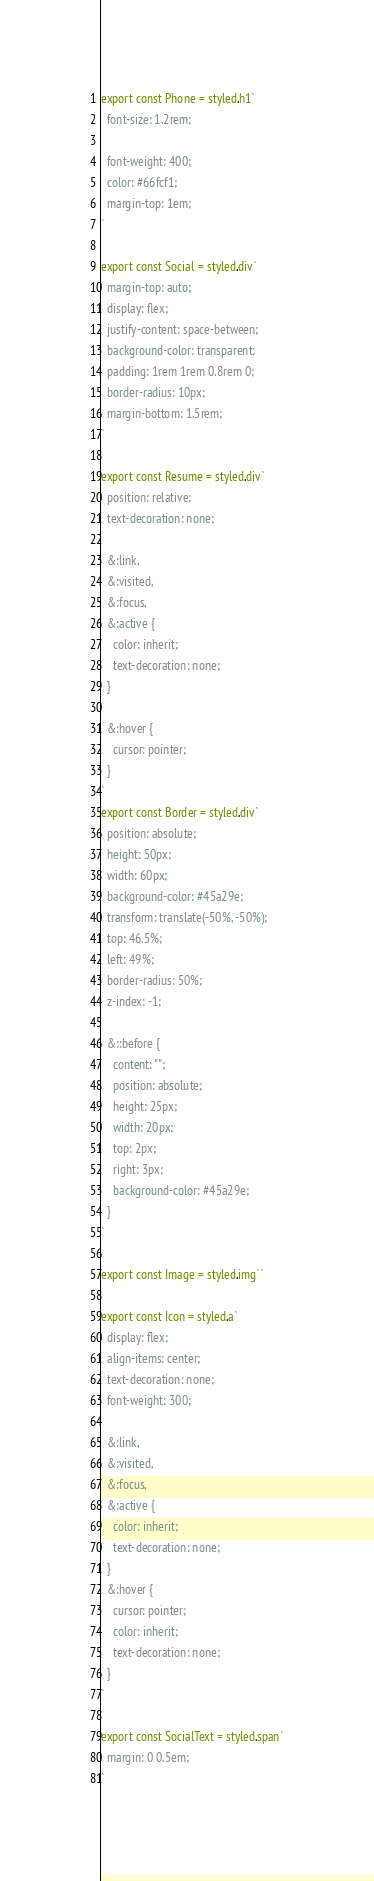Convert code to text. <code><loc_0><loc_0><loc_500><loc_500><_JavaScript_>
export const Phone = styled.h1`
  font-size: 1.2rem;

  font-weight: 400;
  color: #66fcf1;
  margin-top: 1em;
`

export const Social = styled.div`
  margin-top: auto;
  display: flex;
  justify-content: space-between;
  background-color: transparent;
  padding: 1rem 1rem 0.8rem 0;
  border-radius: 10px;
  margin-bottom: 1.5rem;
`

export const Resume = styled.div`
  position: relative;
  text-decoration: none;

  &:link,
  &:visited,
  &:focus,
  &:active {
    color: inherit;
    text-decoration: none;
  }

  &:hover {
    cursor: pointer;
  }
`
export const Border = styled.div`
  position: absolute;
  height: 50px;
  width: 60px;
  background-color: #45a29e;
  transform: translate(-50%, -50%);
  top: 46.5%;
  left: 49%;
  border-radius: 50%;
  z-index: -1;

  &::before {
    content: "";
    position: absolute;
    height: 25px;
    width: 20px;
    top: 2px;
    right: 3px;
    background-color: #45a29e;
  }
`

export const Image = styled.img``

export const Icon = styled.a`
  display: flex;
  align-items: center;
  text-decoration: none;
  font-weight: 300;

  &:link,
  &:visited,
  &:focus,
  &:active {
    color: inherit;
    text-decoration: none;
  }
  &:hover {
    cursor: pointer;
    color: inherit;
    text-decoration: none;
  }
`

export const SocialText = styled.span`
  margin: 0 0.5em;
`
</code> 